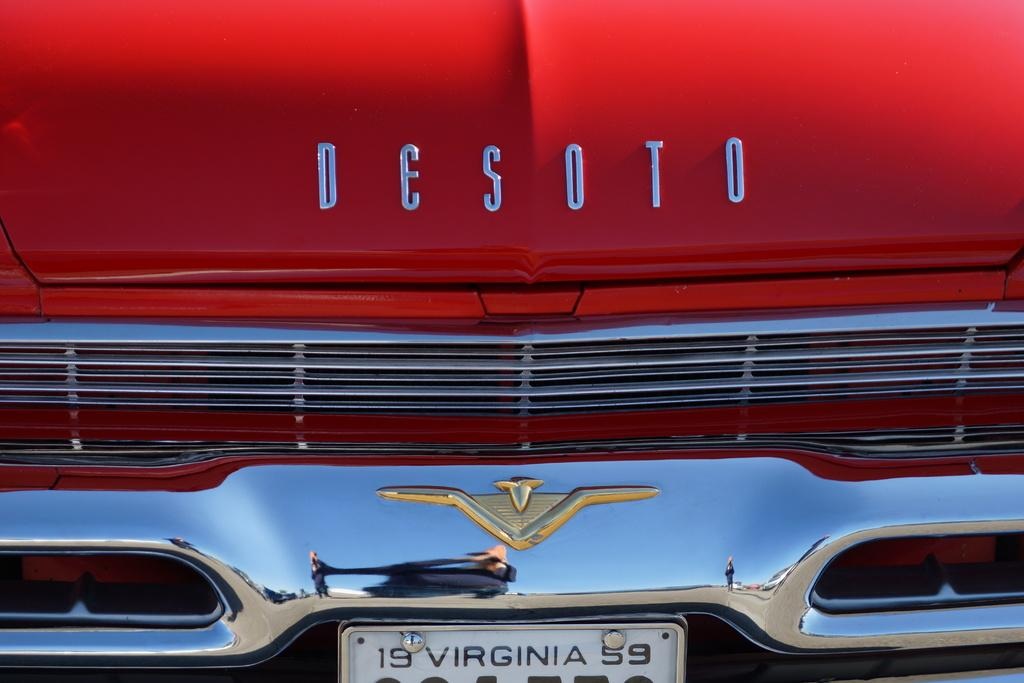What is the main subject of the image? The main subject of the image is a vehicle. Can you identify any specific features of the vehicle? Yes, the vehicle has a name and a logo. What else can be seen in the image related to the vehicle? There is a number board visible in the image. Can you tell me how many snails are crawling on the vehicle in the image? There are no snails present in the image; it features a vehicle with a name, logo, and number board. What type of boat is visible in the image? There is no boat present in the image; it is a zoomed in picture of a vehicle. 